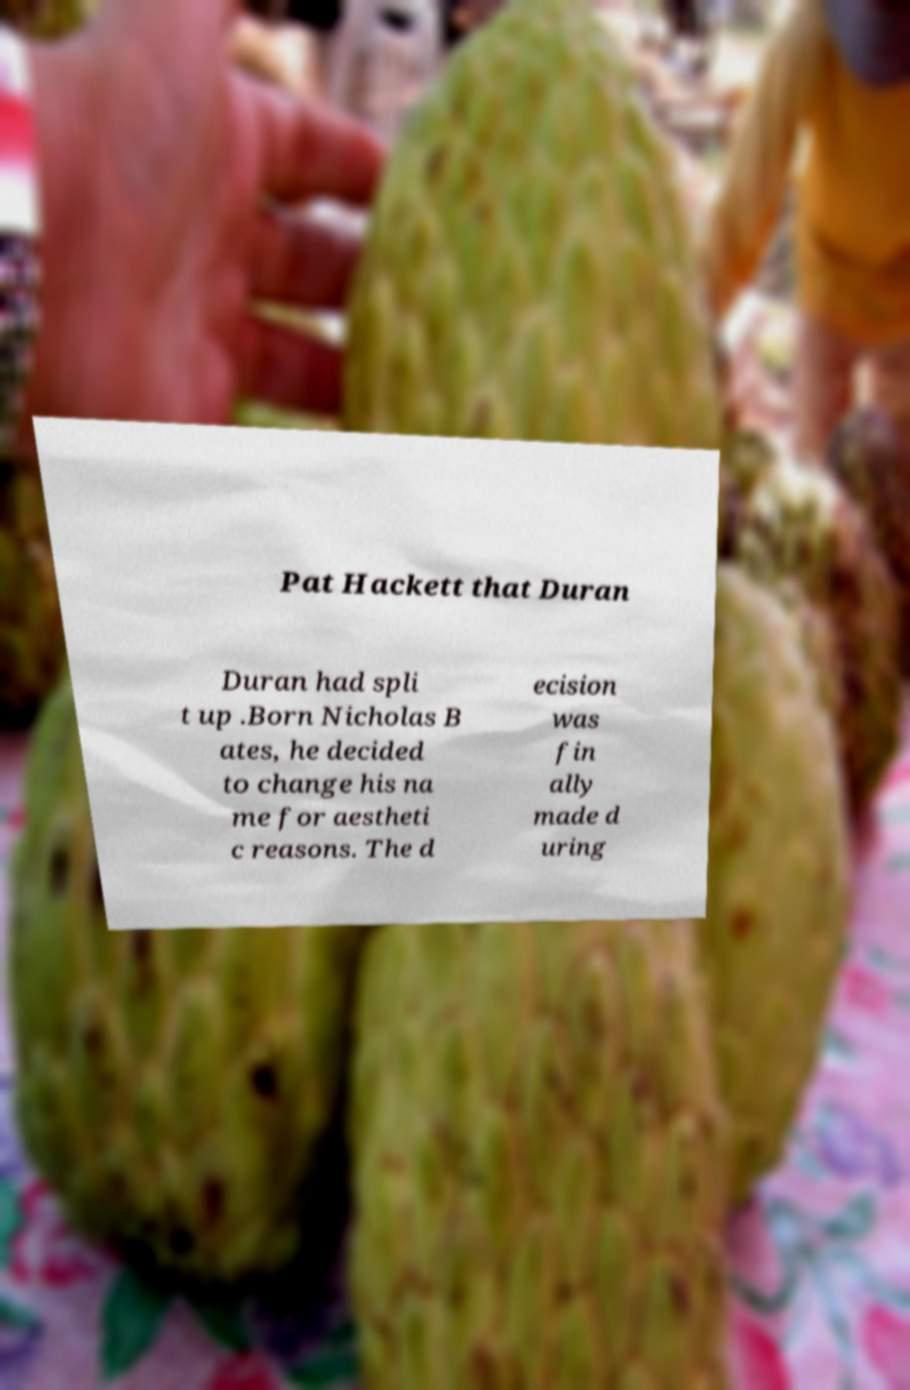What messages or text are displayed in this image? I need them in a readable, typed format. Pat Hackett that Duran Duran had spli t up .Born Nicholas B ates, he decided to change his na me for aestheti c reasons. The d ecision was fin ally made d uring 